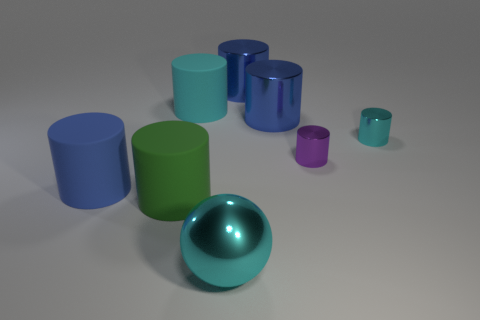Are there any other things that are the same shape as the big cyan shiny thing?
Offer a very short reply. No. What number of cubes are either cyan metal things or purple things?
Provide a succinct answer. 0. What number of green cylinders are there?
Provide a short and direct response. 1. There is a cylinder that is behind the cyan cylinder that is left of the big cyan sphere; what is its size?
Provide a short and direct response. Large. What number of other objects are the same size as the cyan rubber object?
Give a very brief answer. 5. What number of large cyan shiny balls are behind the ball?
Your answer should be very brief. 0. What size is the ball?
Keep it short and to the point. Large. Does the cyan thing that is in front of the blue matte cylinder have the same material as the small cylinder that is in front of the tiny cyan metallic object?
Your response must be concise. Yes. Is there a cylinder that has the same color as the sphere?
Your answer should be compact. Yes. The other shiny cylinder that is the same size as the cyan shiny cylinder is what color?
Make the answer very short. Purple. 